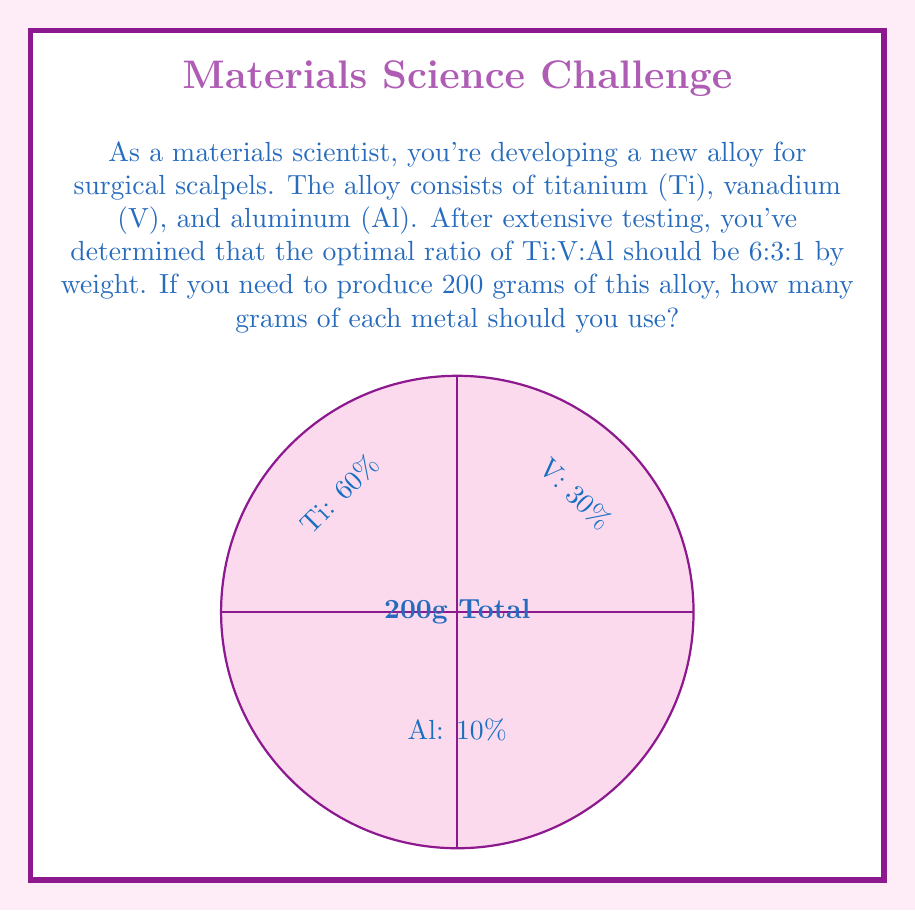Can you answer this question? Let's approach this step-by-step:

1) First, we need to convert the ratio 6:3:1 into percentages:
   Total parts = 6 + 3 + 1 = 10
   Ti: $\frac{6}{10} = 60\%$
   V: $\frac{3}{10} = 30\%$
   Al: $\frac{1}{10} = 10\%$

2) Now, we know the total weight of the alloy is 200g. We can calculate the weight of each metal:

   For Titanium (Ti):
   $$\text{Ti weight} = 200g \times 60\% = 200g \times 0.60 = 120g$$

   For Vanadium (V):
   $$\text{V weight} = 200g \times 30\% = 200g \times 0.30 = 60g$$

   For Aluminum (Al):
   $$\text{Al weight} = 200g \times 10\% = 200g \times 0.10 = 20g$$

3) Let's verify:
   $120g + 60g + 20g = 200g$

Therefore, to produce 200g of the alloy with the optimal ratio, you need 120g of Ti, 60g of V, and 20g of Al.
Answer: Ti: 120g, V: 60g, Al: 20g 